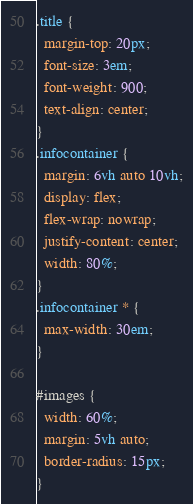Convert code to text. <code><loc_0><loc_0><loc_500><loc_500><_CSS_>.title {
  margin-top: 20px;
  font-size: 3em;
  font-weight: 900;
  text-align: center;
}
.infocontainer {
  margin: 6vh auto 10vh;
  display: flex;
  flex-wrap: nowrap;
  justify-content: center;
  width: 80%;
}
.infocontainer * {
  max-width: 30em;
}

#images {
  width: 60%;
  margin: 5vh auto;
  border-radius: 15px;
}
</code> 